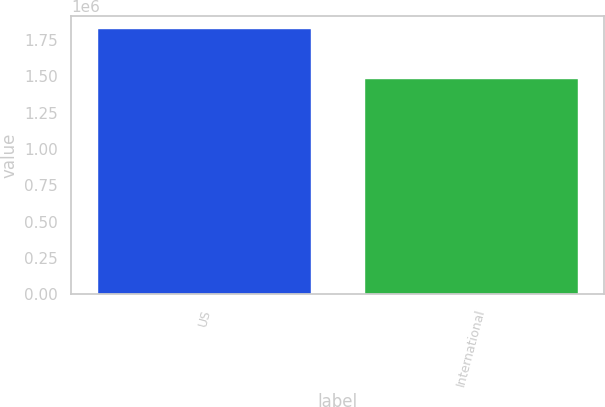<chart> <loc_0><loc_0><loc_500><loc_500><bar_chart><fcel>US<fcel>International<nl><fcel>1.824e+06<fcel>1.483e+06<nl></chart> 